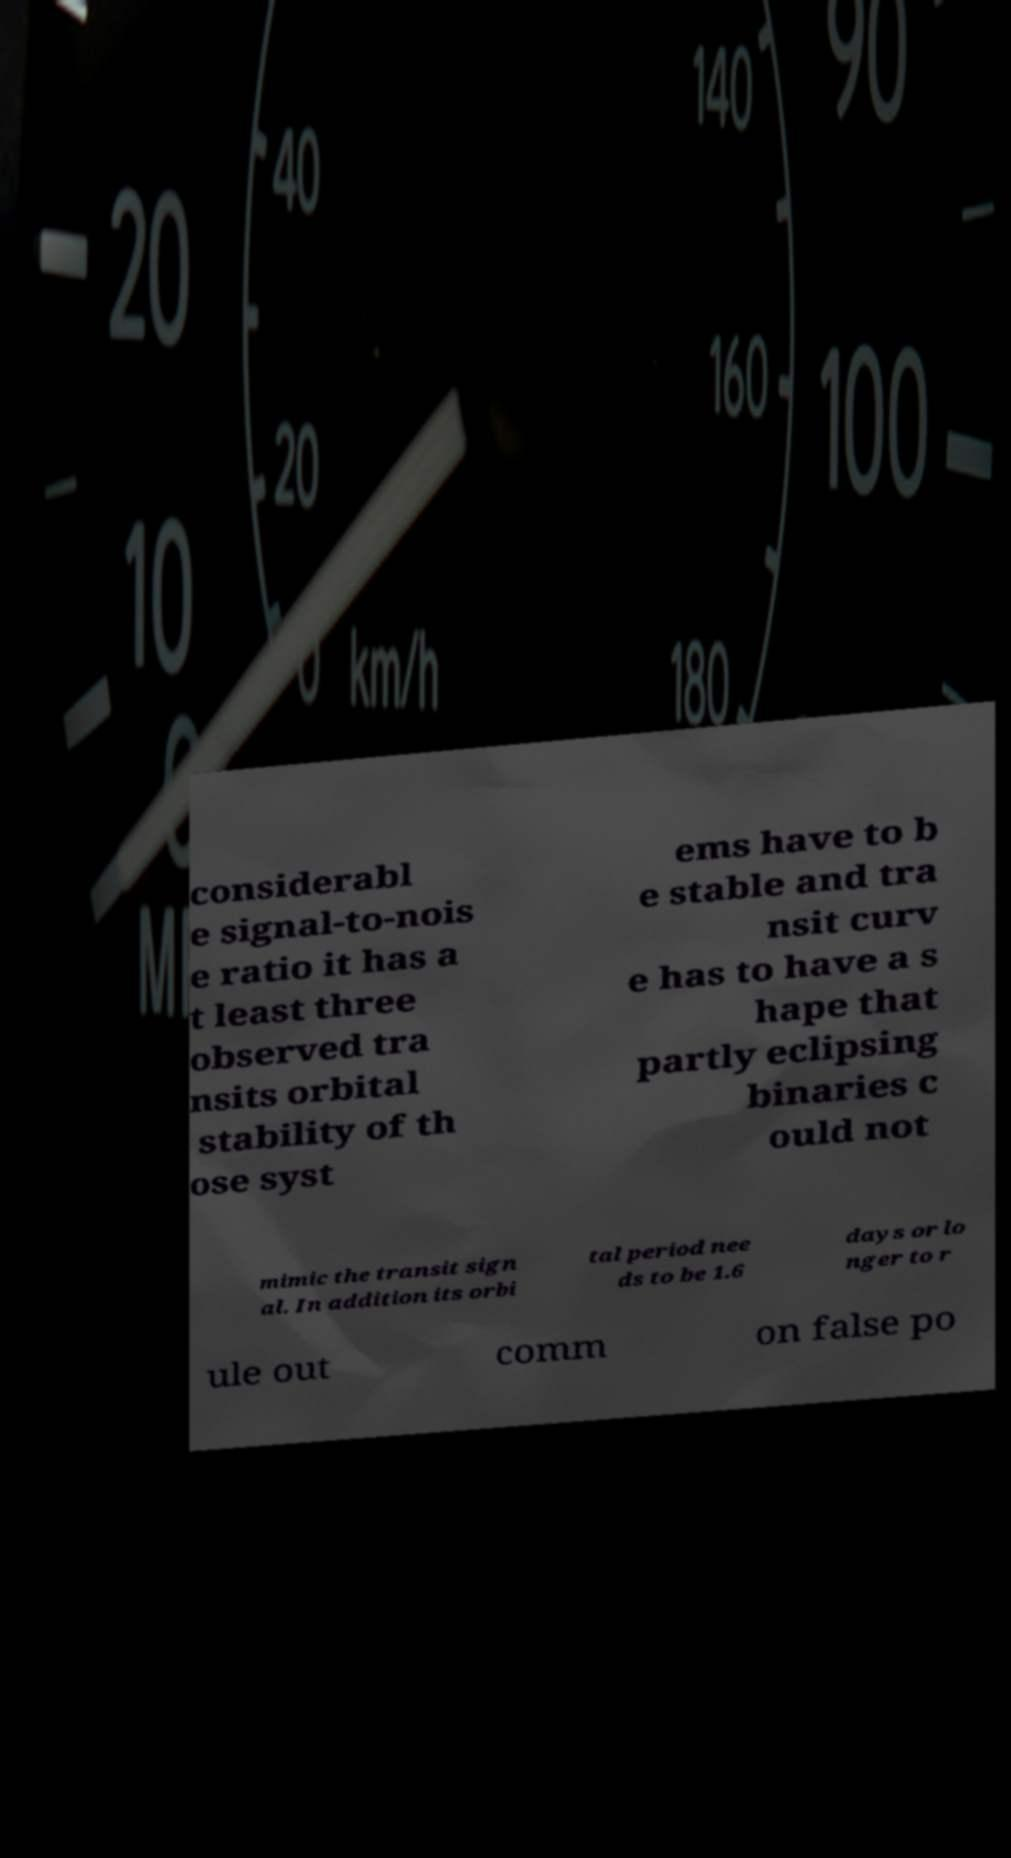Please read and relay the text visible in this image. What does it say? considerabl e signal-to-nois e ratio it has a t least three observed tra nsits orbital stability of th ose syst ems have to b e stable and tra nsit curv e has to have a s hape that partly eclipsing binaries c ould not mimic the transit sign al. In addition its orbi tal period nee ds to be 1.6 days or lo nger to r ule out comm on false po 